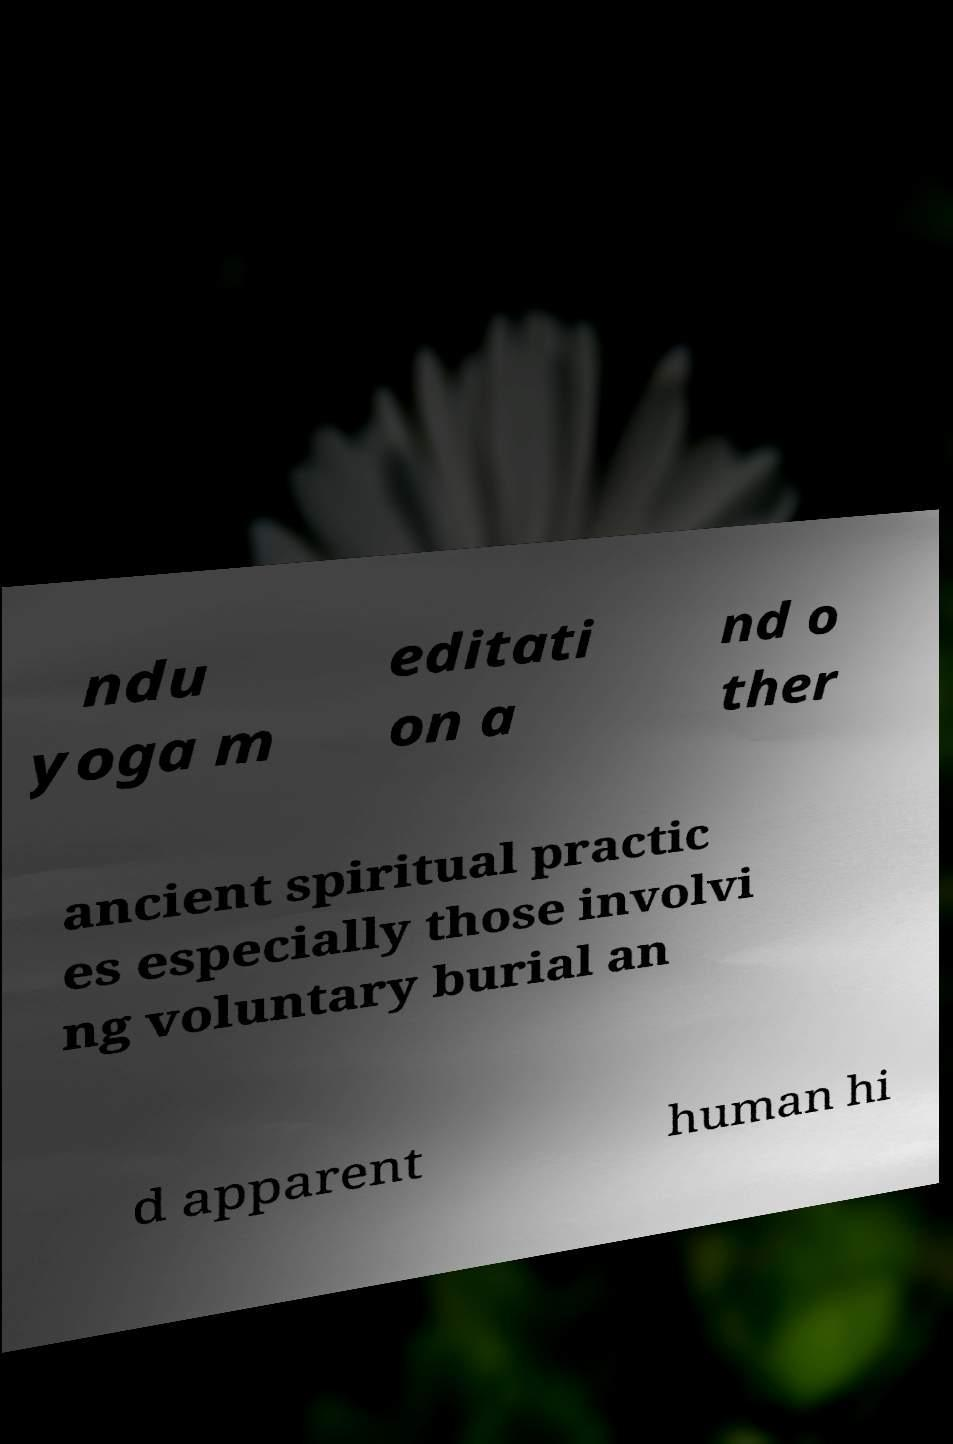Could you assist in decoding the text presented in this image and type it out clearly? ndu yoga m editati on a nd o ther ancient spiritual practic es especially those involvi ng voluntary burial an d apparent human hi 